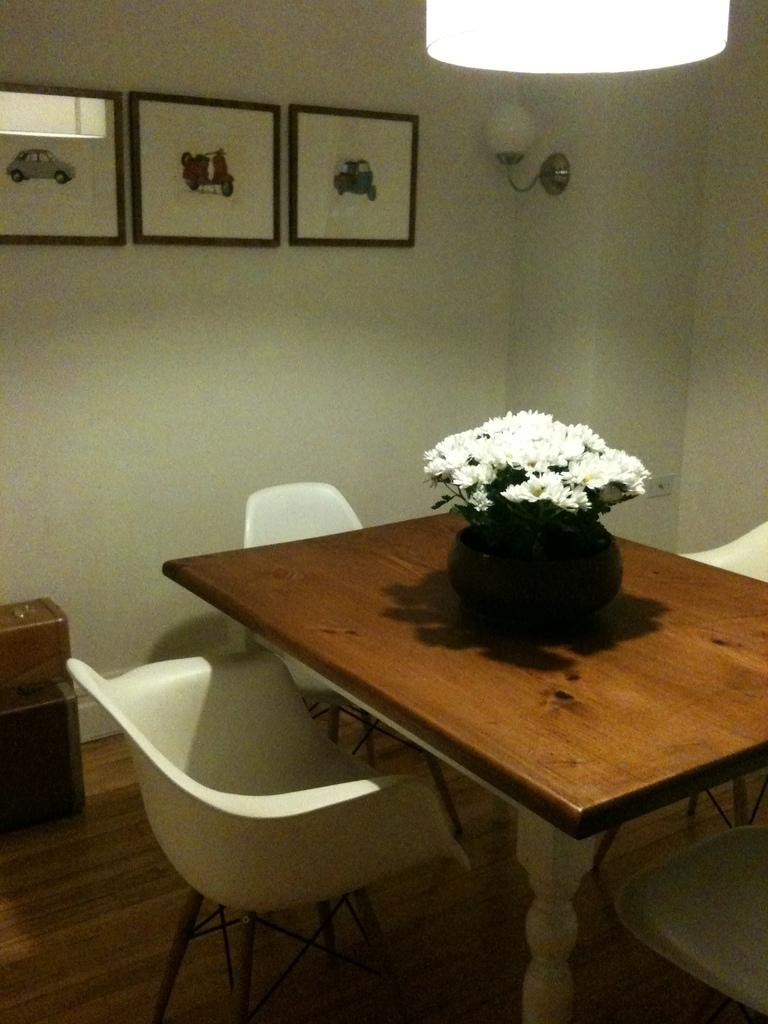Where was the image taken? The image was taken inside a room. What furniture is present in the room? There is a table in the room, and chairs are around the table. What can be found on the table? A flower vase is present on the table. What decorations are on the wall? There are photo frames on the wall. What is the source of light in the room? There is a light fixture at the ceiling. What does the person's dad say about the self in the image? There is no person or self present in the image, so it is not possible to answer that question. 